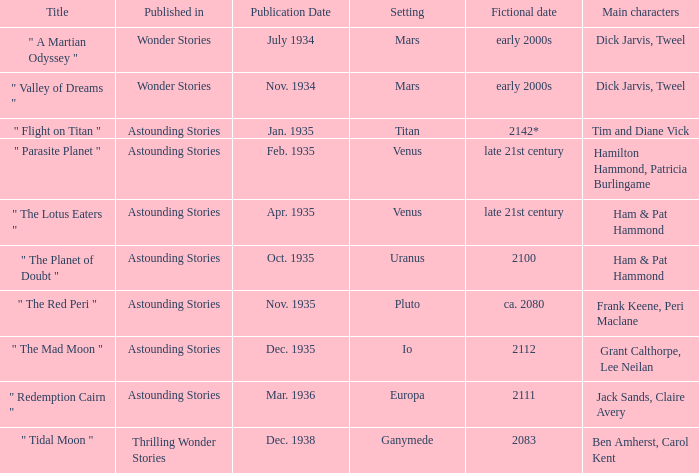Name the publication date when the fictional date is 2112 Dec. 1935. 